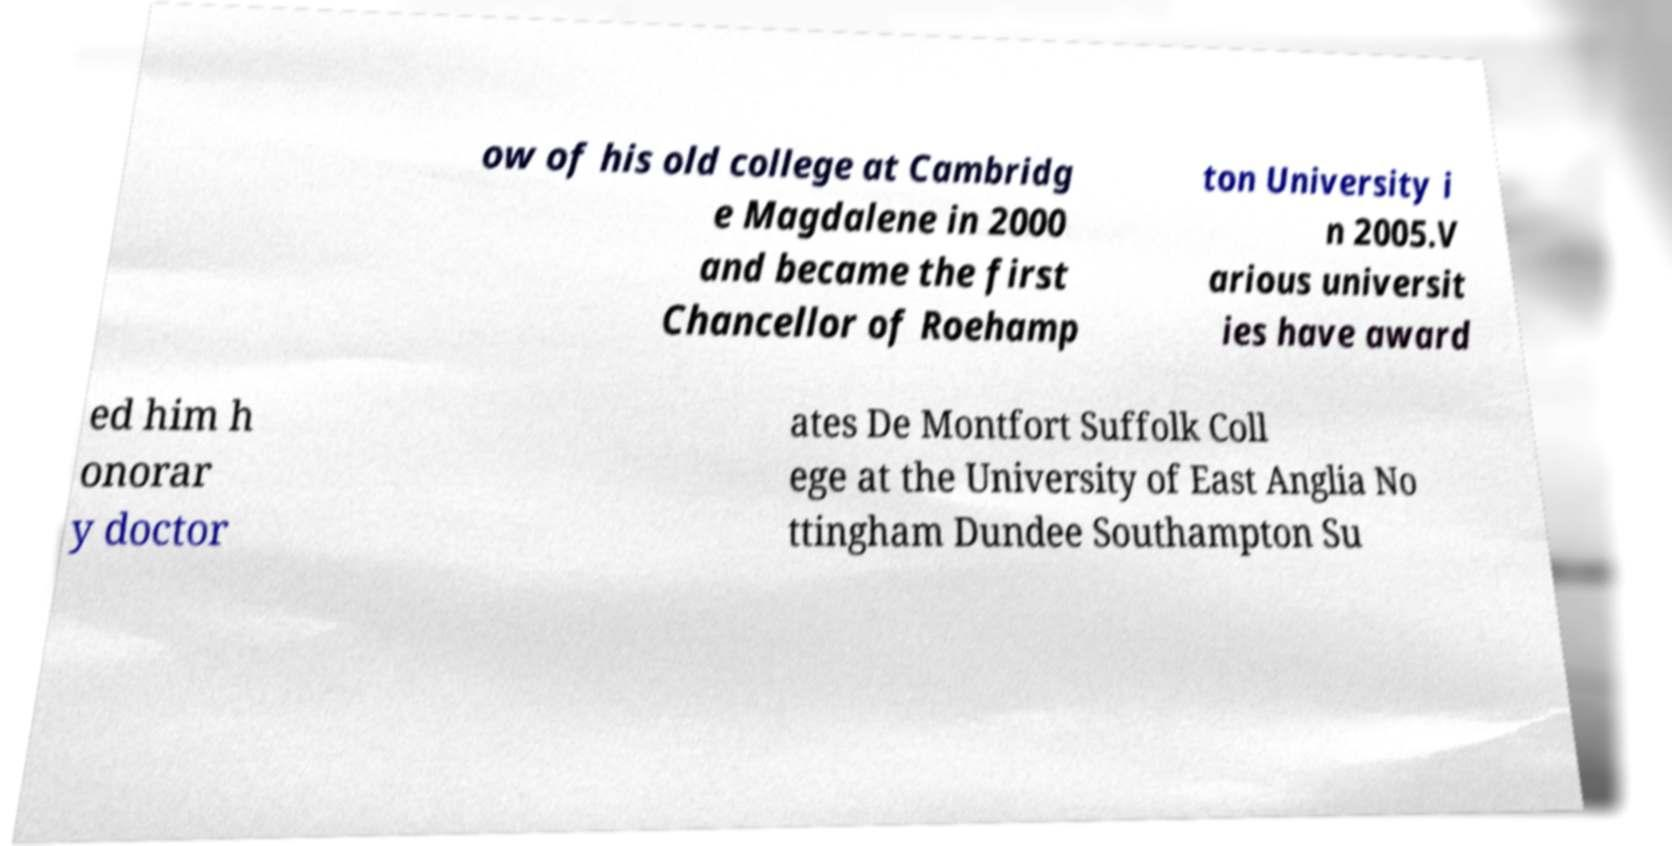What messages or text are displayed in this image? I need them in a readable, typed format. ow of his old college at Cambridg e Magdalene in 2000 and became the first Chancellor of Roehamp ton University i n 2005.V arious universit ies have award ed him h onorar y doctor ates De Montfort Suffolk Coll ege at the University of East Anglia No ttingham Dundee Southampton Su 